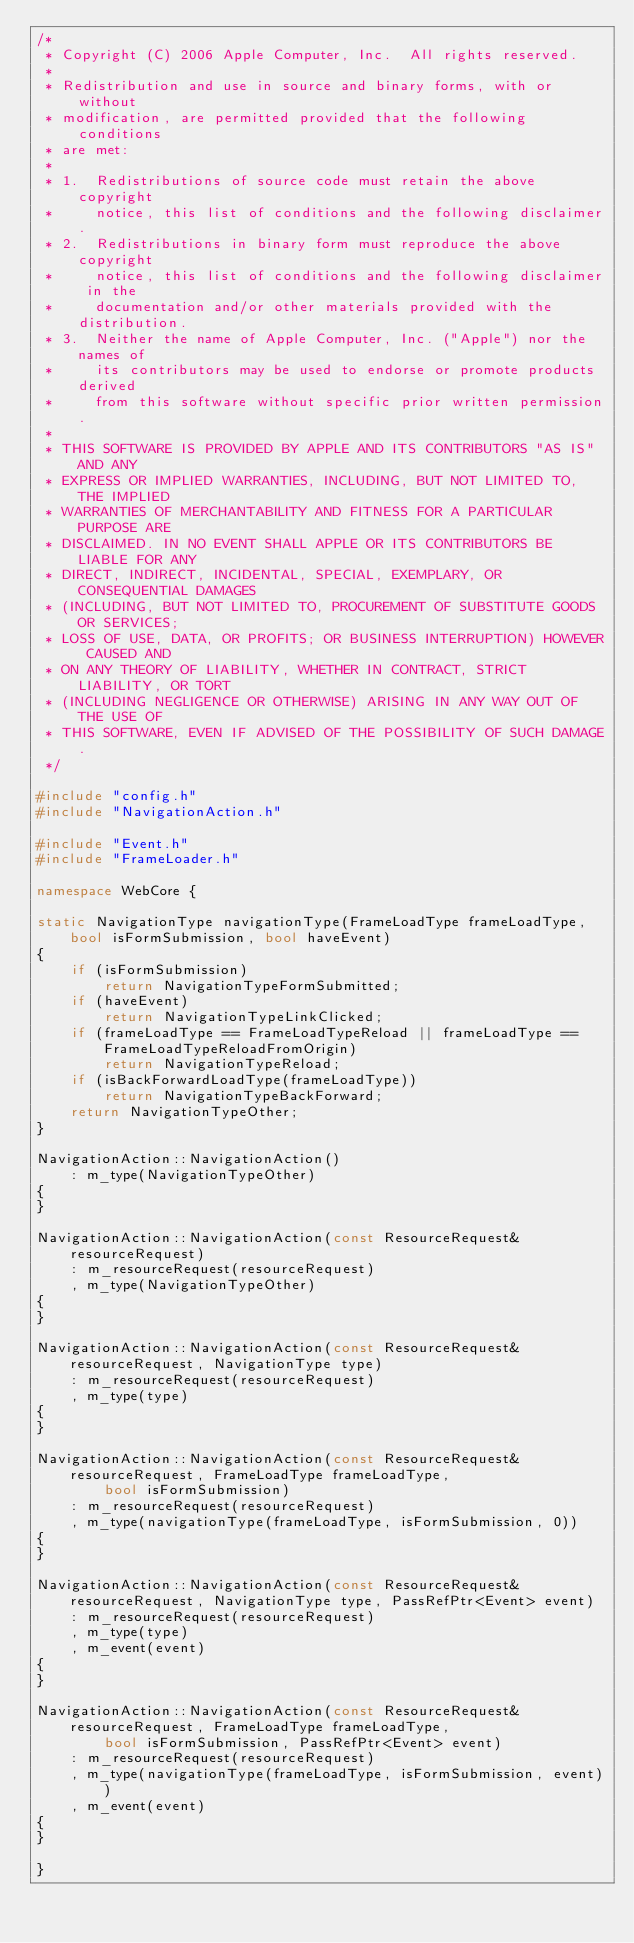Convert code to text. <code><loc_0><loc_0><loc_500><loc_500><_C++_>/*
 * Copyright (C) 2006 Apple Computer, Inc.  All rights reserved.
 *
 * Redistribution and use in source and binary forms, with or without
 * modification, are permitted provided that the following conditions
 * are met:
 *
 * 1.  Redistributions of source code must retain the above copyright
 *     notice, this list of conditions and the following disclaimer. 
 * 2.  Redistributions in binary form must reproduce the above copyright
 *     notice, this list of conditions and the following disclaimer in the
 *     documentation and/or other materials provided with the distribution. 
 * 3.  Neither the name of Apple Computer, Inc. ("Apple") nor the names of
 *     its contributors may be used to endorse or promote products derived
 *     from this software without specific prior written permission. 
 *
 * THIS SOFTWARE IS PROVIDED BY APPLE AND ITS CONTRIBUTORS "AS IS" AND ANY
 * EXPRESS OR IMPLIED WARRANTIES, INCLUDING, BUT NOT LIMITED TO, THE IMPLIED
 * WARRANTIES OF MERCHANTABILITY AND FITNESS FOR A PARTICULAR PURPOSE ARE
 * DISCLAIMED. IN NO EVENT SHALL APPLE OR ITS CONTRIBUTORS BE LIABLE FOR ANY
 * DIRECT, INDIRECT, INCIDENTAL, SPECIAL, EXEMPLARY, OR CONSEQUENTIAL DAMAGES
 * (INCLUDING, BUT NOT LIMITED TO, PROCUREMENT OF SUBSTITUTE GOODS OR SERVICES;
 * LOSS OF USE, DATA, OR PROFITS; OR BUSINESS INTERRUPTION) HOWEVER CAUSED AND
 * ON ANY THEORY OF LIABILITY, WHETHER IN CONTRACT, STRICT LIABILITY, OR TORT
 * (INCLUDING NEGLIGENCE OR OTHERWISE) ARISING IN ANY WAY OUT OF THE USE OF
 * THIS SOFTWARE, EVEN IF ADVISED OF THE POSSIBILITY OF SUCH DAMAGE.
 */

#include "config.h"
#include "NavigationAction.h"

#include "Event.h"
#include "FrameLoader.h"

namespace WebCore {

static NavigationType navigationType(FrameLoadType frameLoadType, bool isFormSubmission, bool haveEvent)
{
    if (isFormSubmission)
        return NavigationTypeFormSubmitted;
    if (haveEvent)
        return NavigationTypeLinkClicked;
    if (frameLoadType == FrameLoadTypeReload || frameLoadType == FrameLoadTypeReloadFromOrigin)
        return NavigationTypeReload;
    if (isBackForwardLoadType(frameLoadType))
        return NavigationTypeBackForward;
    return NavigationTypeOther;
}

NavigationAction::NavigationAction()
    : m_type(NavigationTypeOther)
{
}

NavigationAction::NavigationAction(const ResourceRequest& resourceRequest)
    : m_resourceRequest(resourceRequest)
    , m_type(NavigationTypeOther)
{
}

NavigationAction::NavigationAction(const ResourceRequest& resourceRequest, NavigationType type)
    : m_resourceRequest(resourceRequest)
    , m_type(type)
{
}

NavigationAction::NavigationAction(const ResourceRequest& resourceRequest, FrameLoadType frameLoadType,
        bool isFormSubmission)
    : m_resourceRequest(resourceRequest)
    , m_type(navigationType(frameLoadType, isFormSubmission, 0))
{
}

NavigationAction::NavigationAction(const ResourceRequest& resourceRequest, NavigationType type, PassRefPtr<Event> event)
    : m_resourceRequest(resourceRequest)
    , m_type(type)
    , m_event(event)
{
}

NavigationAction::NavigationAction(const ResourceRequest& resourceRequest, FrameLoadType frameLoadType,
        bool isFormSubmission, PassRefPtr<Event> event)
    : m_resourceRequest(resourceRequest)
    , m_type(navigationType(frameLoadType, isFormSubmission, event))
    , m_event(event)
{
}

}
</code> 